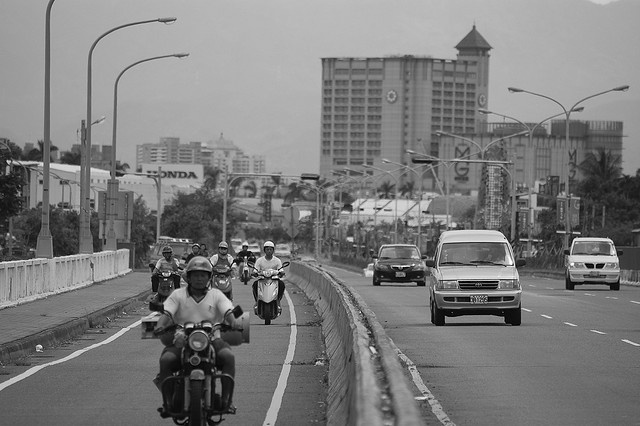Describe the objects in this image and their specific colors. I can see car in darkgray, gray, black, and lightgray tones, motorcycle in darkgray, black, gray, and lightgray tones, people in darkgray, black, gray, and lightgray tones, car in darkgray, gray, black, and lightgray tones, and car in darkgray, gray, black, and lightgray tones in this image. 